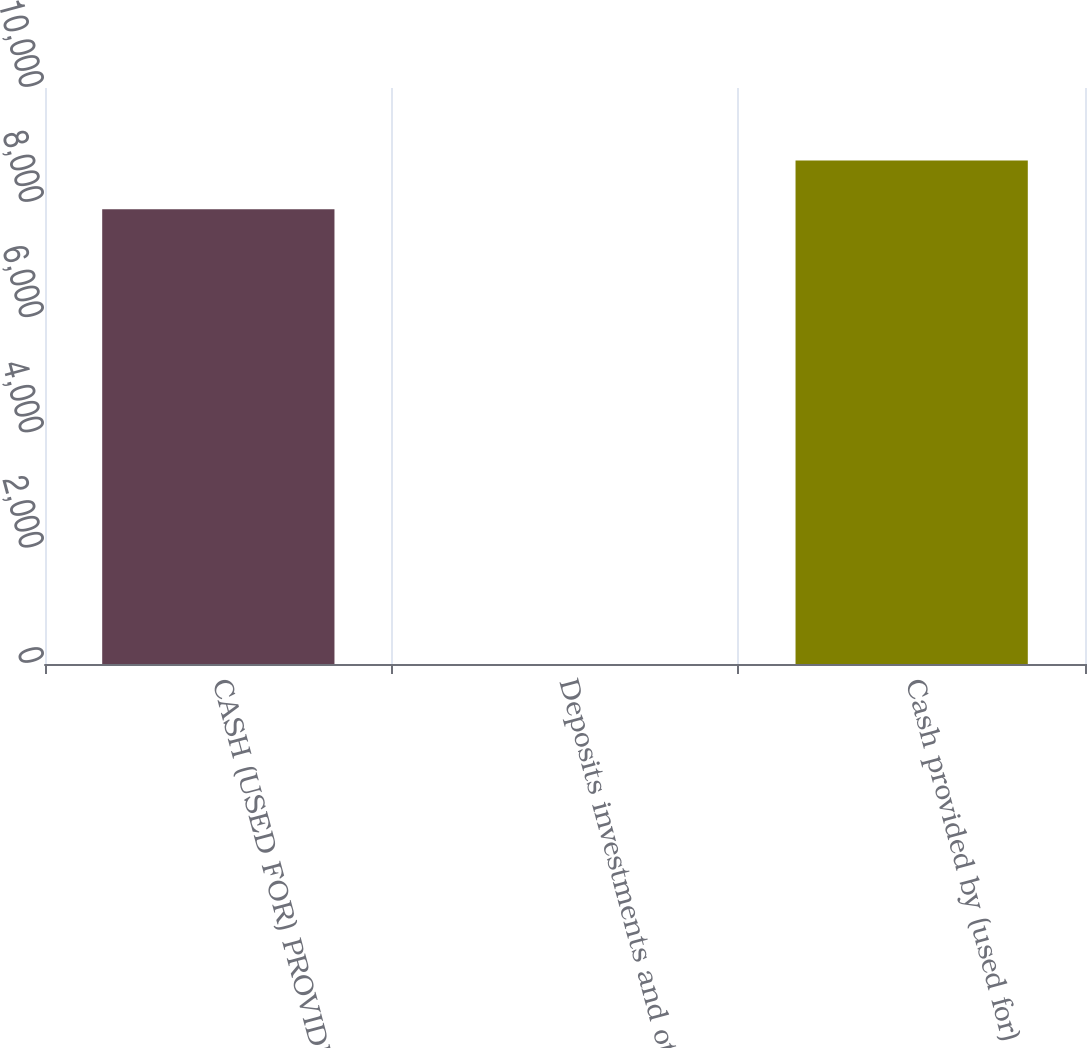<chart> <loc_0><loc_0><loc_500><loc_500><bar_chart><fcel>CASH (USED FOR) PROVIDED BY<fcel>Deposits investments and other<fcel>Cash provided by (used for)<nl><fcel>7897<fcel>2<fcel>8743.3<nl></chart> 